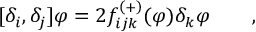Convert formula to latex. <formula><loc_0><loc_0><loc_500><loc_500>[ \delta _ { i } , \delta _ { j } ] \varphi = 2 f _ { i j k } ^ { \left ( + \right ) } ( \varphi ) \delta _ { k } \varphi \quad ,</formula> 